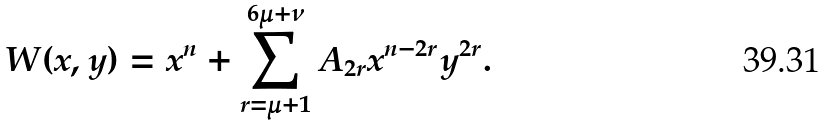Convert formula to latex. <formula><loc_0><loc_0><loc_500><loc_500>W ( x , y ) = x ^ { n } + \sum _ { r = \mu + 1 } ^ { 6 \mu + \nu } A _ { 2 r } x ^ { n - 2 r } y ^ { 2 r } .</formula> 